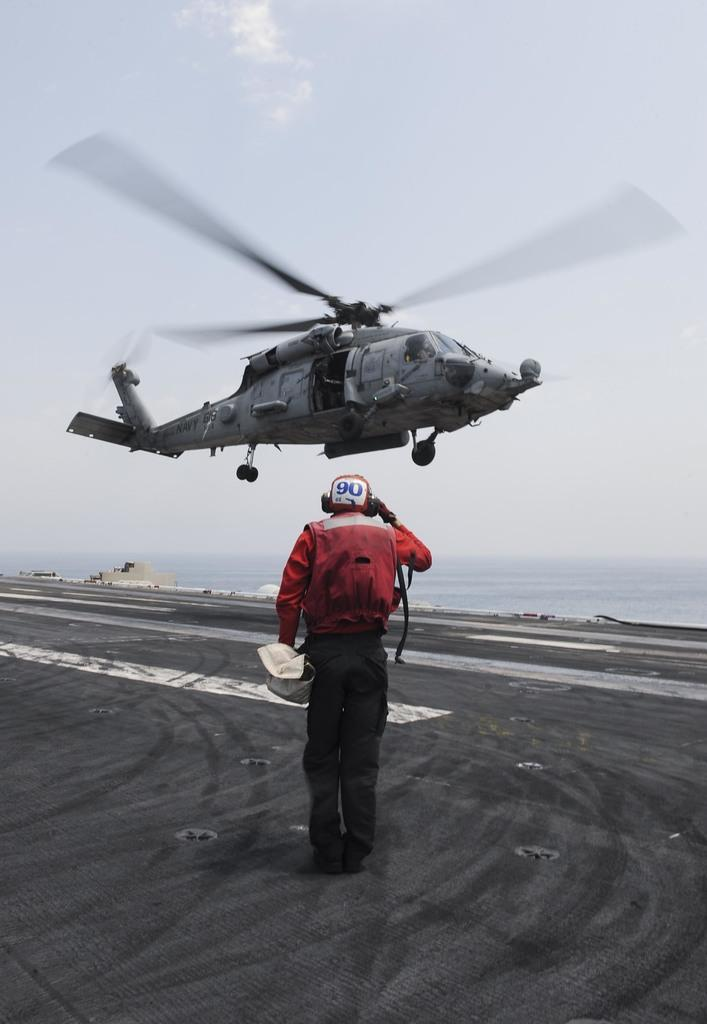What is the main subject of the image? There is a person standing in the image. What is the person wearing? The person is wearing a black and red color dress. What can be seen in the background of the image? There is an aircraft in the background of the image. What is the color of the sky in the image? The sky is white in color. How many dogs are present in the image? There are no dogs present in the image. What type of root can be seen growing near the person in the image? There is no root visible in the image; it features a person standing and an aircraft in the background. 